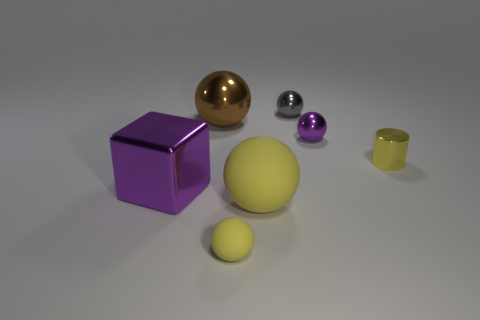Do the yellow cylinder and the gray shiny ball have the same size?
Provide a succinct answer. Yes. Is there a small ball that has the same material as the big yellow ball?
Keep it short and to the point. Yes. There is a shiny cylinder that is the same color as the small matte sphere; what size is it?
Provide a short and direct response. Small. What number of objects are in front of the big brown thing and on the left side of the gray object?
Keep it short and to the point. 3. What is the material of the purple thing left of the gray metal thing?
Your answer should be compact. Metal. How many balls are the same color as the metallic cylinder?
Keep it short and to the point. 2. The purple ball that is the same material as the large purple block is what size?
Offer a very short reply. Small. What number of things are either tiny yellow cylinders or purple metal things?
Make the answer very short. 3. What is the color of the small matte thing that is in front of the small purple metal sphere?
Your response must be concise. Yellow. What size is the purple thing that is the same shape as the big brown thing?
Offer a terse response. Small. 